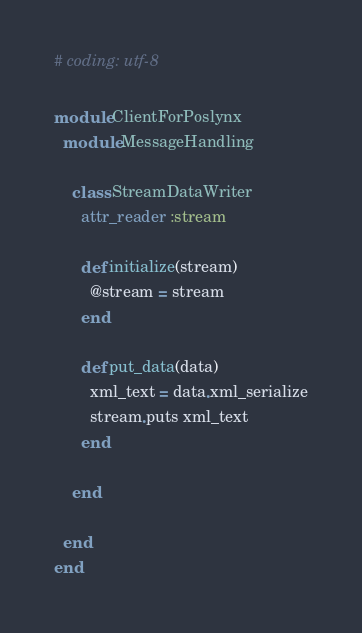<code> <loc_0><loc_0><loc_500><loc_500><_Ruby_># coding: utf-8

module ClientForPoslynx
  module MessageHandling

    class StreamDataWriter
      attr_reader :stream

      def initialize(stream)
        @stream = stream
      end

      def put_data(data)
        xml_text = data.xml_serialize
        stream.puts xml_text
      end

    end

  end
end
</code> 